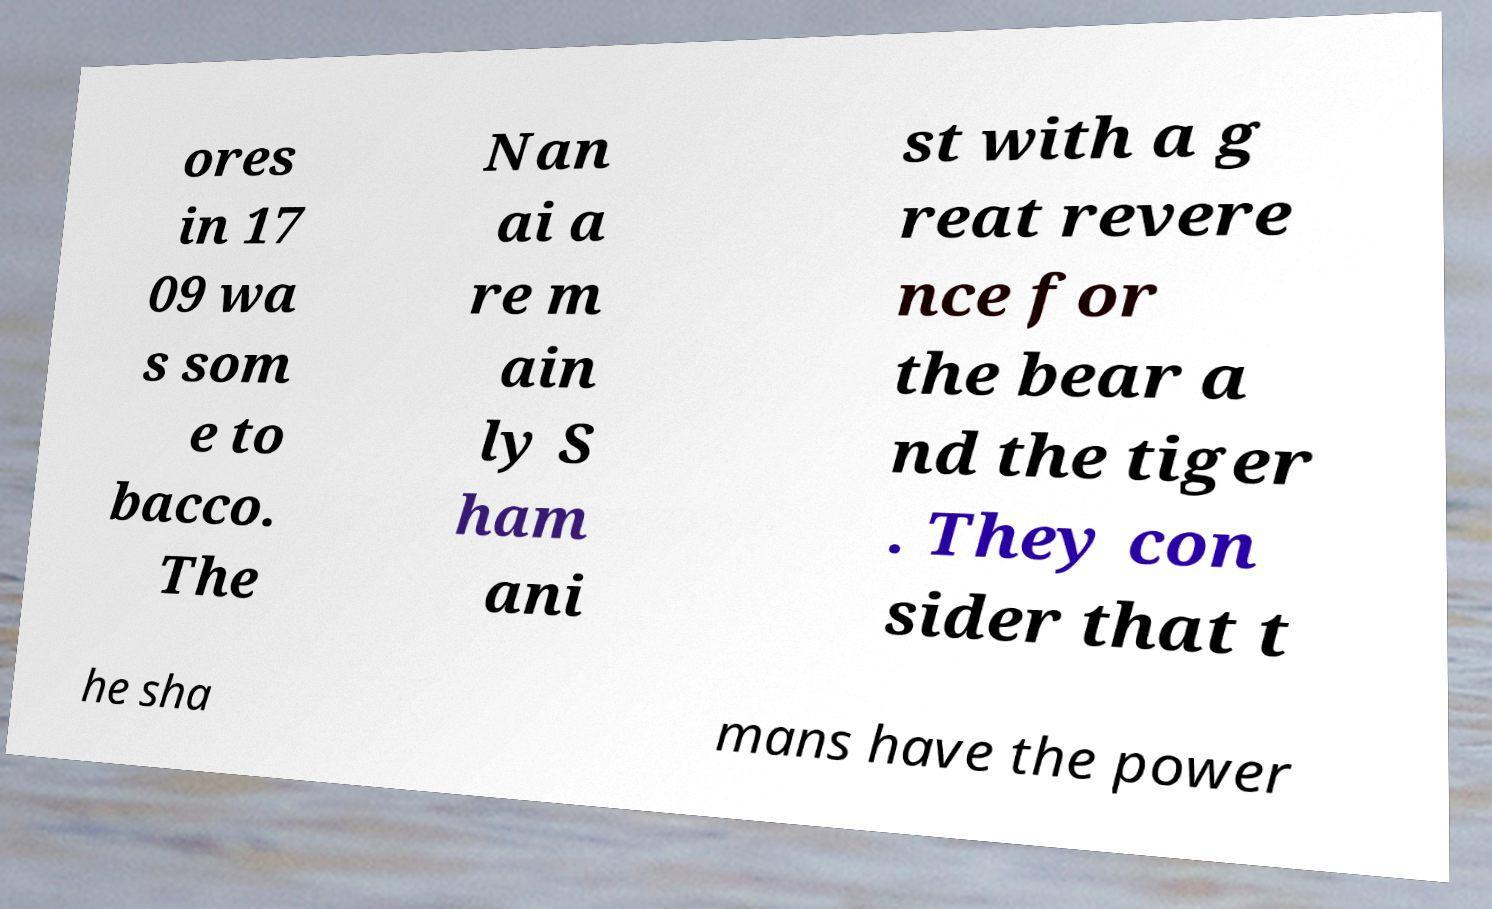What messages or text are displayed in this image? I need them in a readable, typed format. ores in 17 09 wa s som e to bacco. The Nan ai a re m ain ly S ham ani st with a g reat revere nce for the bear a nd the tiger . They con sider that t he sha mans have the power 